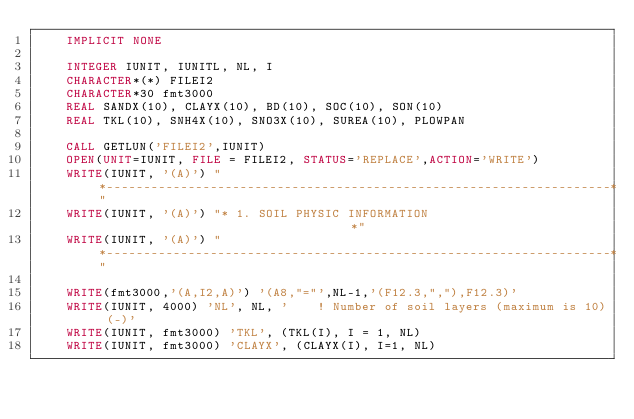Convert code to text. <code><loc_0><loc_0><loc_500><loc_500><_FORTRAN_>    IMPLICIT NONE
    
    INTEGER IUNIT, IUNITL, NL, I
    CHARACTER*(*) FILEI2
    CHARACTER*30 fmt3000
    REAL SANDX(10), CLAYX(10), BD(10), SOC(10), SON(10)
    REAL TKL(10), SNH4X(10), SNO3X(10), SUREA(10), PLOWPAN
    
    CALL GETLUN('FILEI2',IUNIT)
    OPEN(UNIT=IUNIT, FILE = FILEI2, STATUS='REPLACE',ACTION='WRITE')
    WRITE(IUNIT, '(A)') "*--------------------------------------------------------------------*"
    WRITE(IUNIT, '(A)') "* 1. SOIL PHYSIC INFORMATION                                   *"
    WRITE(IUNIT, '(A)') "*--------------------------------------------------------------------*"
    
    WRITE(fmt3000,'(A,I2,A)') '(A8,"="',NL-1,'(F12.3,","),F12.3)'
    WRITE(IUNIT, 4000) 'NL', NL, '    ! Number of soil layers (maximum is 10) (-)'
    WRITE(IUNIT, fmt3000) 'TKL', (TKL(I), I = 1, NL)
    WRITE(IUNIT, fmt3000) 'CLAYX', (CLAYX(I), I=1, NL)</code> 